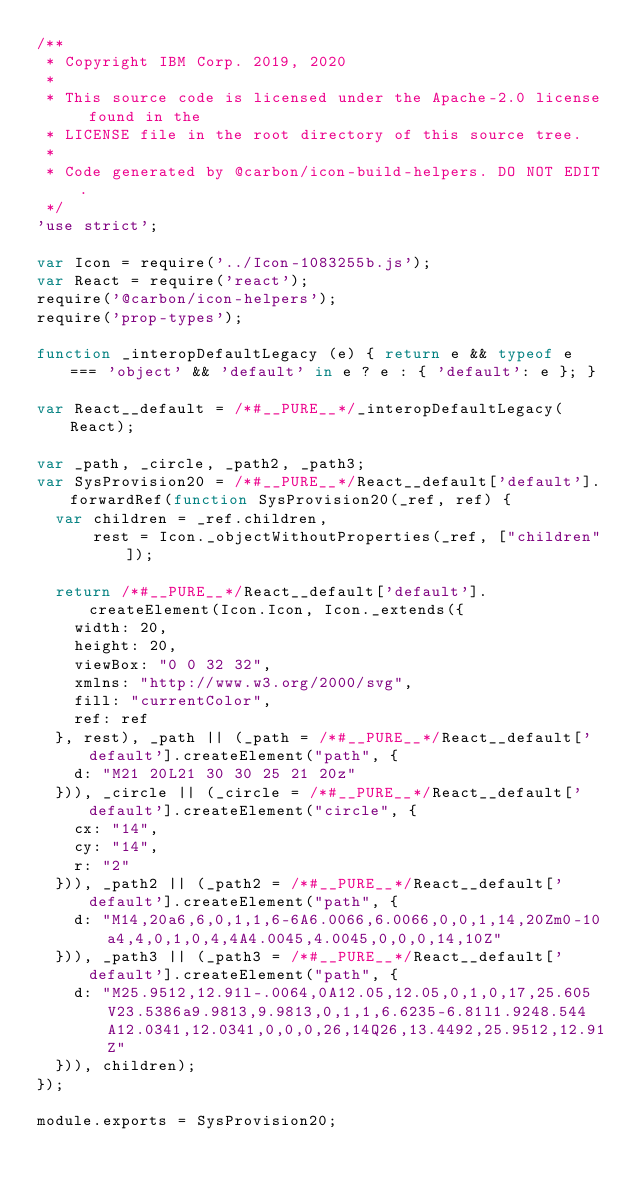<code> <loc_0><loc_0><loc_500><loc_500><_JavaScript_>/**
 * Copyright IBM Corp. 2019, 2020
 *
 * This source code is licensed under the Apache-2.0 license found in the
 * LICENSE file in the root directory of this source tree.
 *
 * Code generated by @carbon/icon-build-helpers. DO NOT EDIT.
 */
'use strict';

var Icon = require('../Icon-1083255b.js');
var React = require('react');
require('@carbon/icon-helpers');
require('prop-types');

function _interopDefaultLegacy (e) { return e && typeof e === 'object' && 'default' in e ? e : { 'default': e }; }

var React__default = /*#__PURE__*/_interopDefaultLegacy(React);

var _path, _circle, _path2, _path3;
var SysProvision20 = /*#__PURE__*/React__default['default'].forwardRef(function SysProvision20(_ref, ref) {
  var children = _ref.children,
      rest = Icon._objectWithoutProperties(_ref, ["children"]);

  return /*#__PURE__*/React__default['default'].createElement(Icon.Icon, Icon._extends({
    width: 20,
    height: 20,
    viewBox: "0 0 32 32",
    xmlns: "http://www.w3.org/2000/svg",
    fill: "currentColor",
    ref: ref
  }, rest), _path || (_path = /*#__PURE__*/React__default['default'].createElement("path", {
    d: "M21 20L21 30 30 25 21 20z"
  })), _circle || (_circle = /*#__PURE__*/React__default['default'].createElement("circle", {
    cx: "14",
    cy: "14",
    r: "2"
  })), _path2 || (_path2 = /*#__PURE__*/React__default['default'].createElement("path", {
    d: "M14,20a6,6,0,1,1,6-6A6.0066,6.0066,0,0,1,14,20Zm0-10a4,4,0,1,0,4,4A4.0045,4.0045,0,0,0,14,10Z"
  })), _path3 || (_path3 = /*#__PURE__*/React__default['default'].createElement("path", {
    d: "M25.9512,12.91l-.0064,0A12.05,12.05,0,1,0,17,25.605V23.5386a9.9813,9.9813,0,1,1,6.6235-6.81l1.9248.544A12.0341,12.0341,0,0,0,26,14Q26,13.4492,25.9512,12.91Z"
  })), children);
});

module.exports = SysProvision20;
</code> 